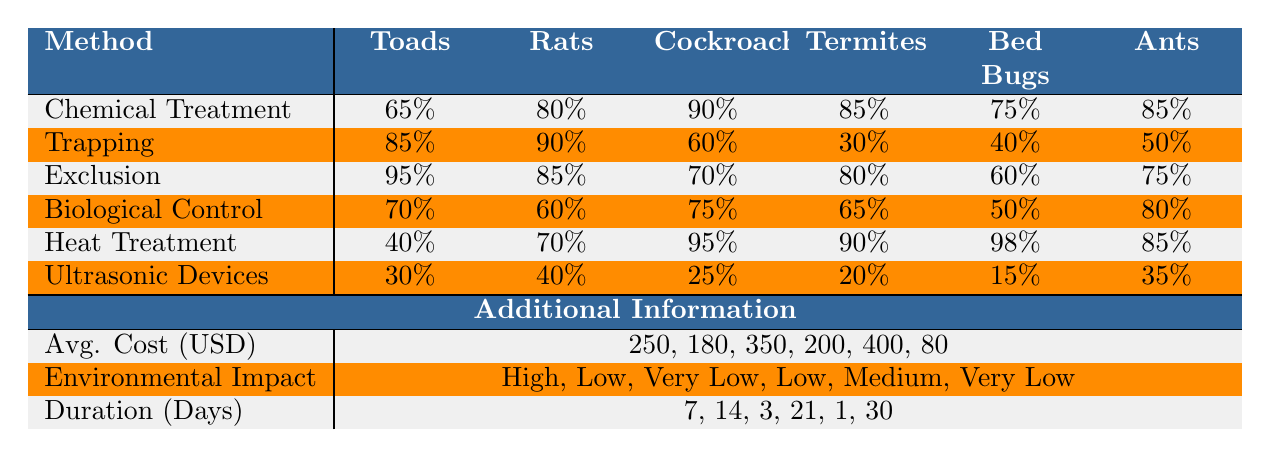What is the success rate of Chemical Treatment for removing Toads? The table shows the success rate of Chemical Treatment for Toads is 65%.
Answer: 65% Which pest removal method has the highest success rate for Exclusion against Toads? The table indicates that the success rate of Exclusion for Toads is 95%, which is the highest success rate listed for Toads.
Answer: 95% What is the average cost of using Trapping as a pest removal method? The average cost for Trapping, as stated in the table, is $180.
Answer: 180 Which method has the lowest success rate for Cockroaches? According to the table, Ultrasonic Devices have the lowest success rate for Cockroaches at 25%.
Answer: 25% True or False: Heat Treatment is the most effective method for removing Bed Bugs. The success rate for Bed Bugs with Heat Treatment is 98%, which is the highest in the table, so it is true.
Answer: True What is the difference in success rates between Exclusion and Biological Control for Rats? The success rate of Exclusion for Rats is 85%, and for Biological Control, it is 60%. The difference is 85% - 60% = 25%.
Answer: 25% Which method has the highest environmental impact and what is its impact level? The table shows that Chemical Treatment has a high environmental impact level, which is the most significant impact listed.
Answer: High If you sum the success rates of Trapping for all pests, what is the total? The success rates for Trapping are 85% (Toads) + 90% (Rats) + 60% (Cockroaches) + 30% (Termites) + 40% (Bed Bugs) + 50% (Ants) = 355%.
Answer: 355% What is the method with the second-highest success rate for Toads? Trapping has a success rate of 85% for Toads, while Exclusion has the highest at 95%, making Trapping the second-highest.
Answer: 85% What is the success rate for Ultrasonic Devices when targeting Termites? The table states that the success rate for Ultrasonic Devices against Termites is 20%.
Answer: 20% 